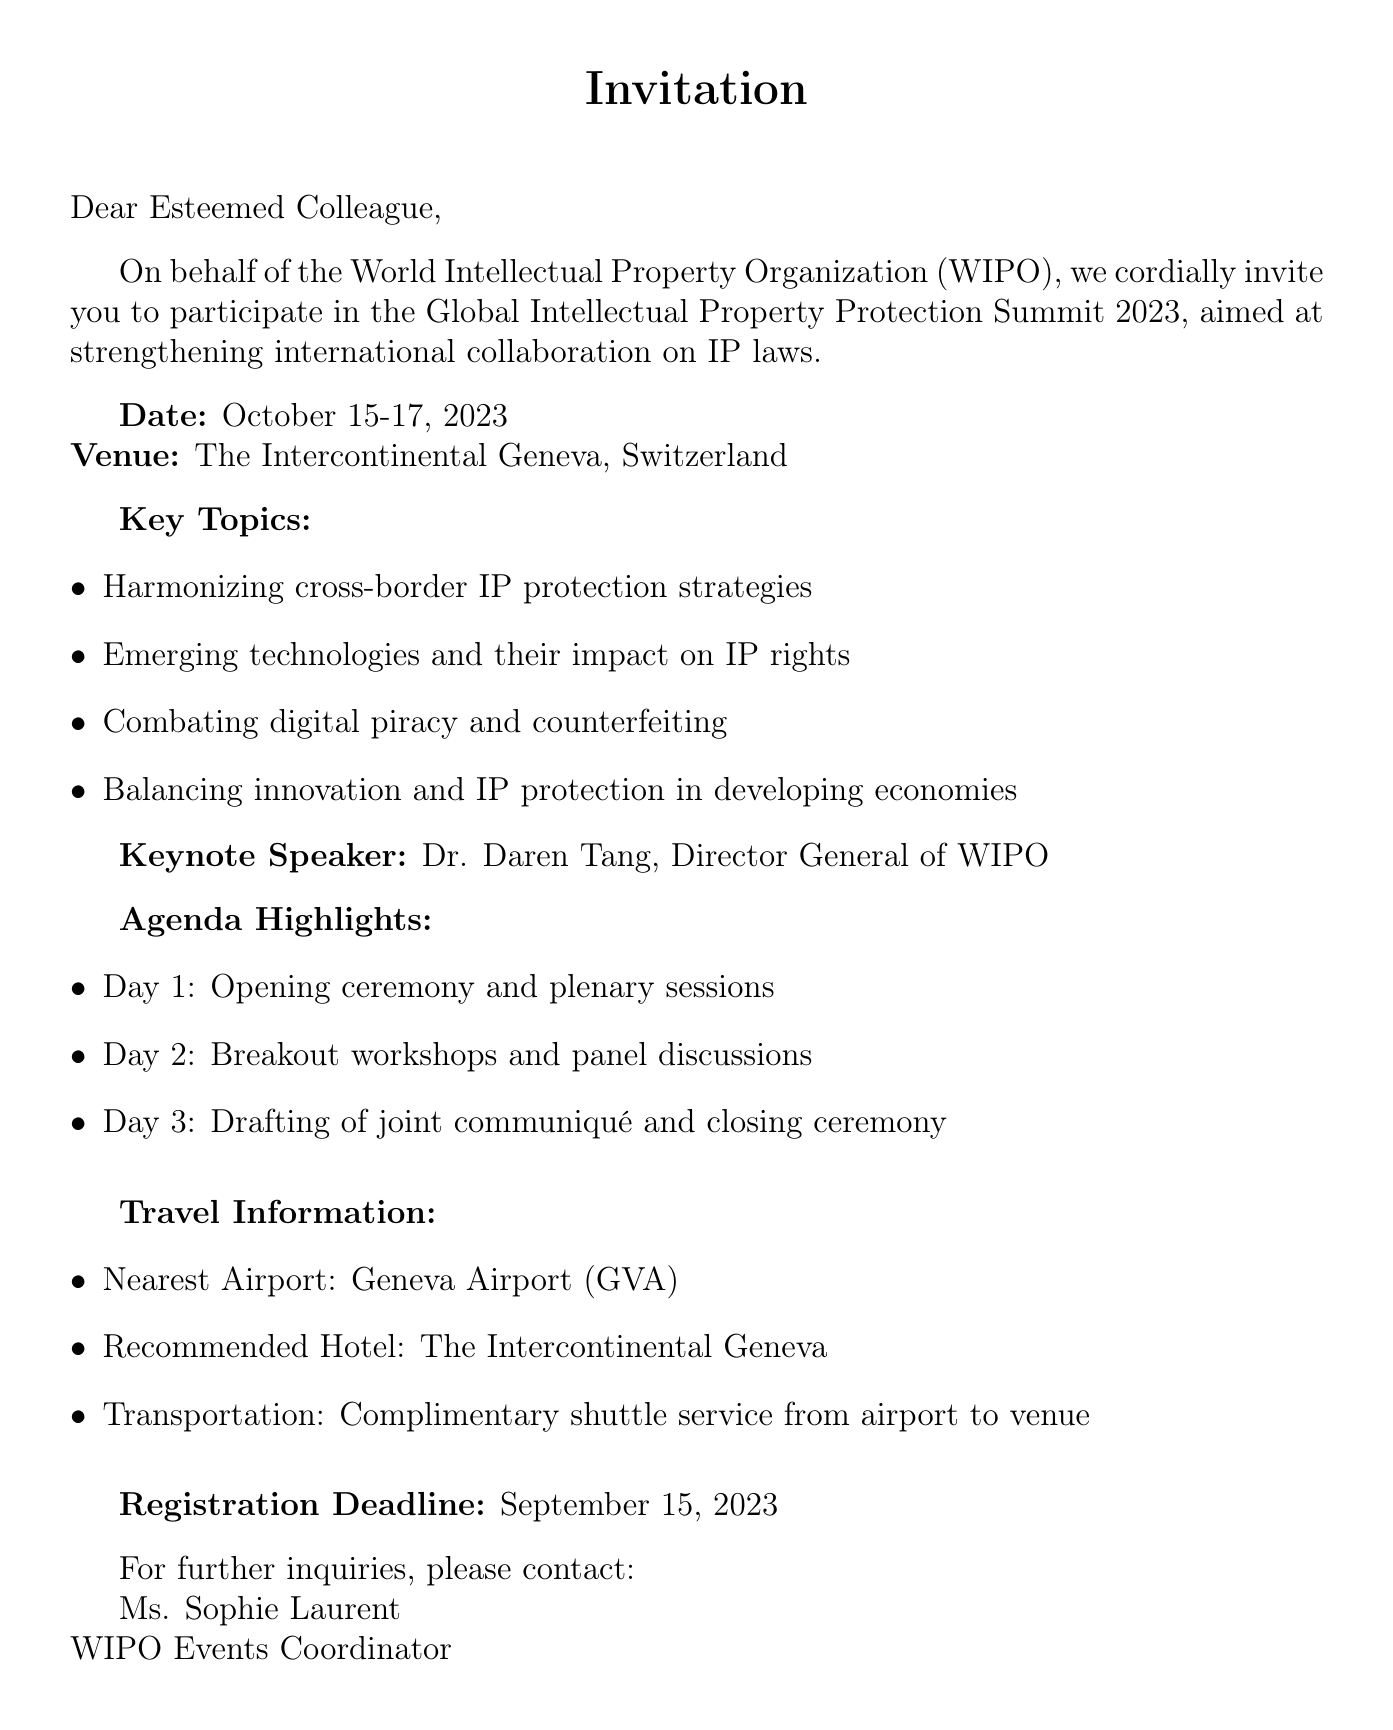What is the title of the symposium? The title of the symposium is stated at the beginning of the document.
Answer: Global Intellectual Property Protection Summit 2023 Who is the keynote speaker? The document explicitly mentions the keynote speaker's name.
Answer: Dr. Daren Tang When is the registration deadline? The document clearly states the deadline for registration.
Answer: September 15, 2023 What are the dates for the event? The event dates are provided in the introductory section of the document.
Answer: October 15-17, 2023 What is the recommended hotel? The recommended hotel for the event is mentioned under the travel information section.
Answer: The Intercontinental Geneva What is one of the key topics discussed at the symposium? The document lists several key topics to give insight into the content of the symposium.
Answer: Harmonizing cross-border IP protection strategies What is the nearest airport to the venue? The nearest airport is specified under the travel information section of the document.
Answer: Geneva Airport (GVA) What does the agenda for day 1 include? The document outlines the agenda highlighting activities for each day, particularly for day 1.
Answer: Opening ceremony and plenary sessions What is the organizing body of the symposium? The document identifies the organization responsible for the symposium.
Answer: World Intellectual Property Organization (WIPO) 